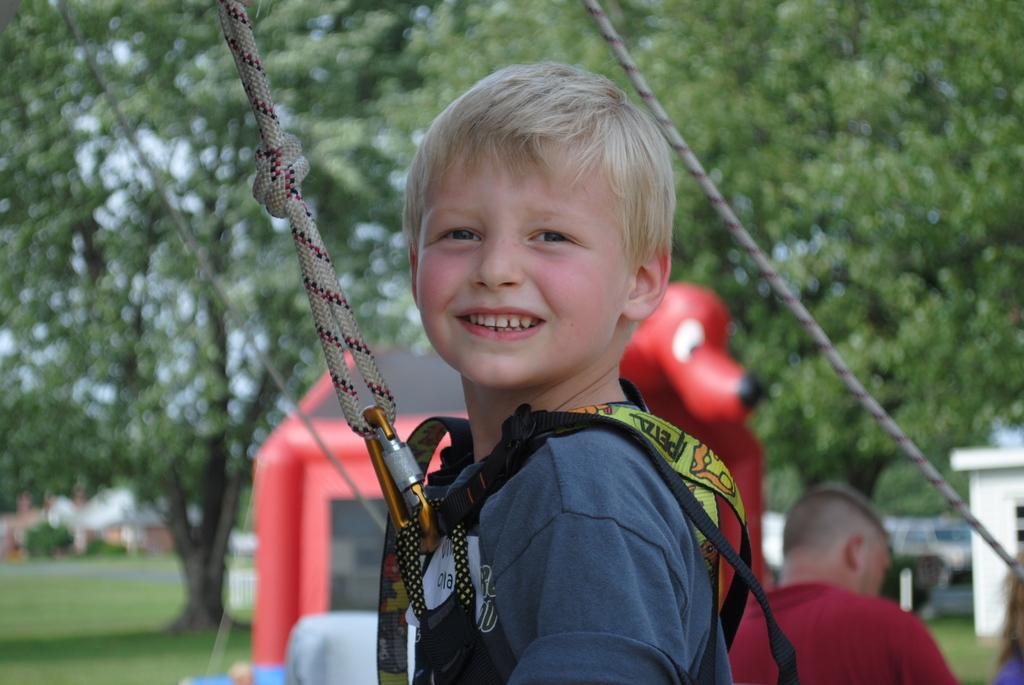Can you describe this image briefly? This picture is clicked outside. In the foreground there is a kid smiling and seems to be standing on the ground and there is a rope attached to the dress of a kid. In the background we can see the trees, buildings, green grass, a person and some toys. 